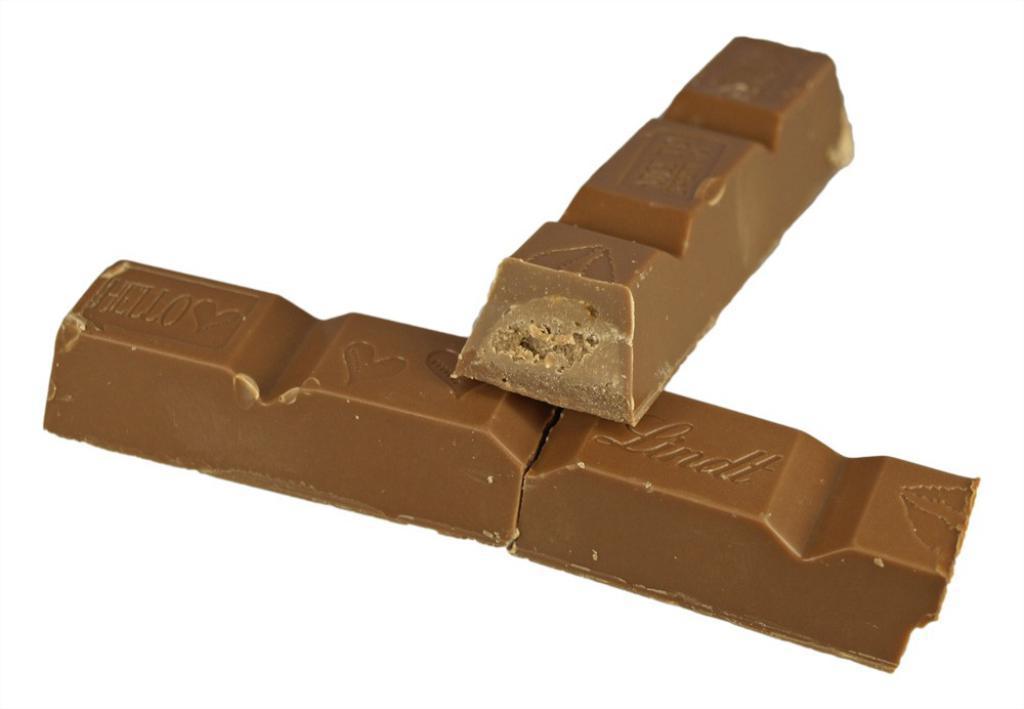Could you give a brief overview of what you see in this image? In this image I can see two chocolate bars which are brown in color on the white colored background. 